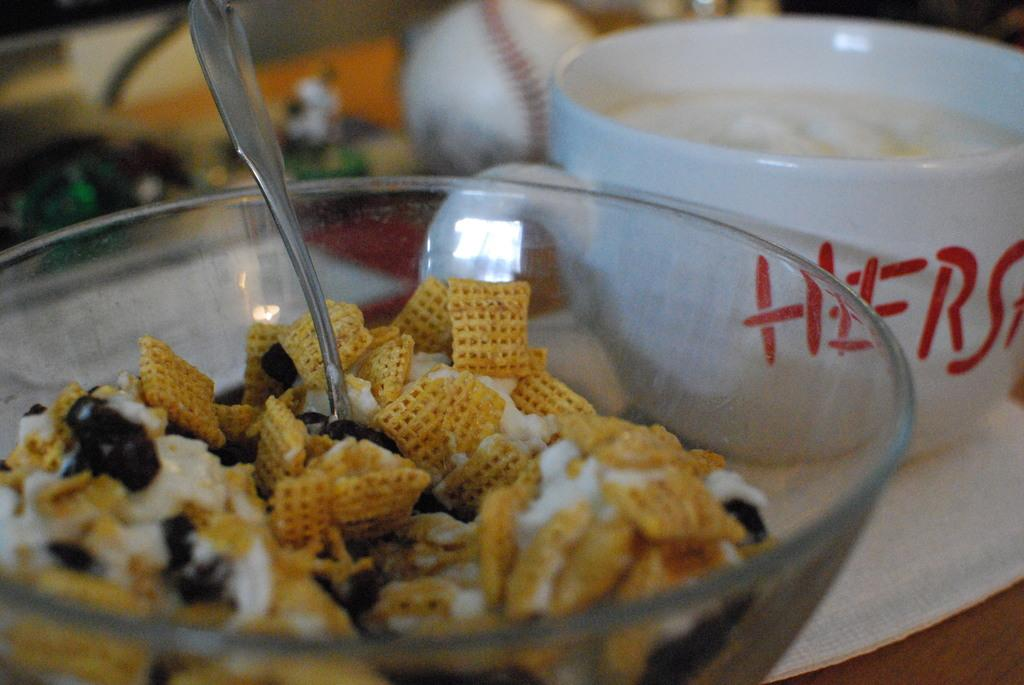What piece of furniture is present in the image? There is a table in the image. How many bowls are on the table? There are two bowls on the table. What is inside the bowls? There is a food item in the bowls. Is there any utensil in the bowls? Yes, there is a spoon in one of the bowls. Can you describe the background of the image? The background of the image is blurred. What type of competition is taking place on the table in the image? There is no competition present in the image; it features a table with two bowls containing a food item and a spoon. 